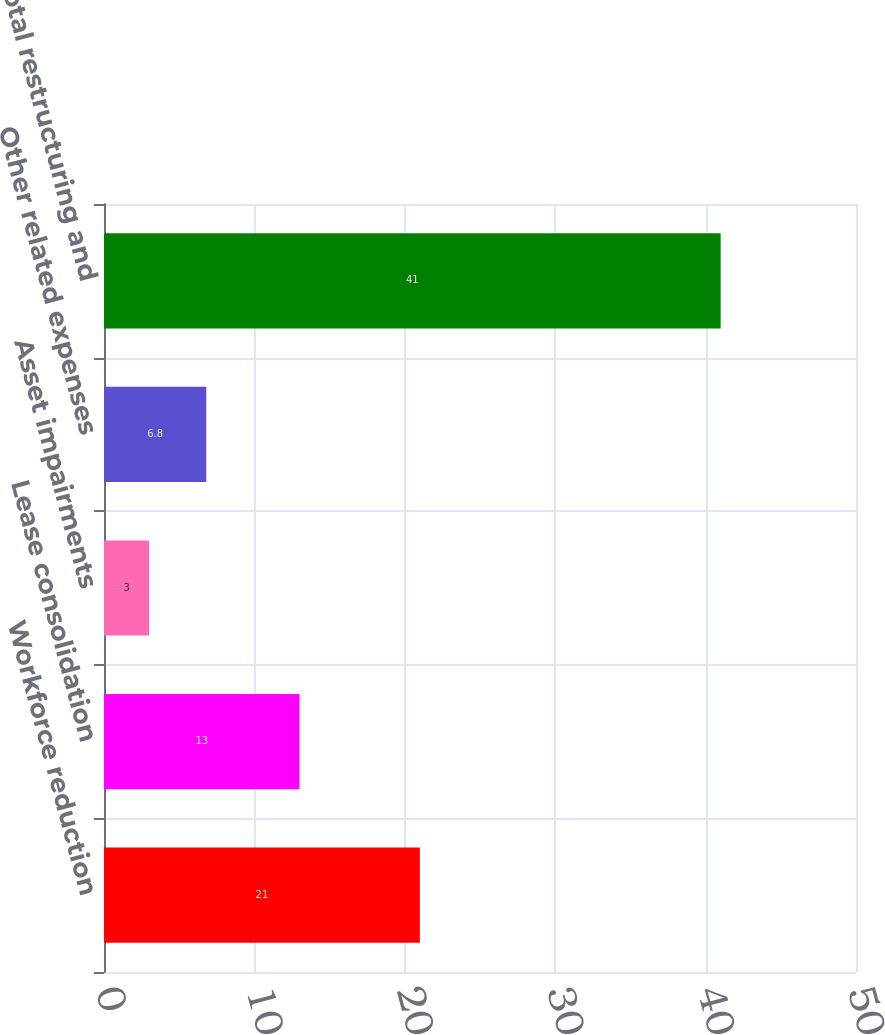Convert chart. <chart><loc_0><loc_0><loc_500><loc_500><bar_chart><fcel>Workforce reduction<fcel>Lease consolidation<fcel>Asset impairments<fcel>Other related expenses<fcel>Total restructuring and<nl><fcel>21<fcel>13<fcel>3<fcel>6.8<fcel>41<nl></chart> 